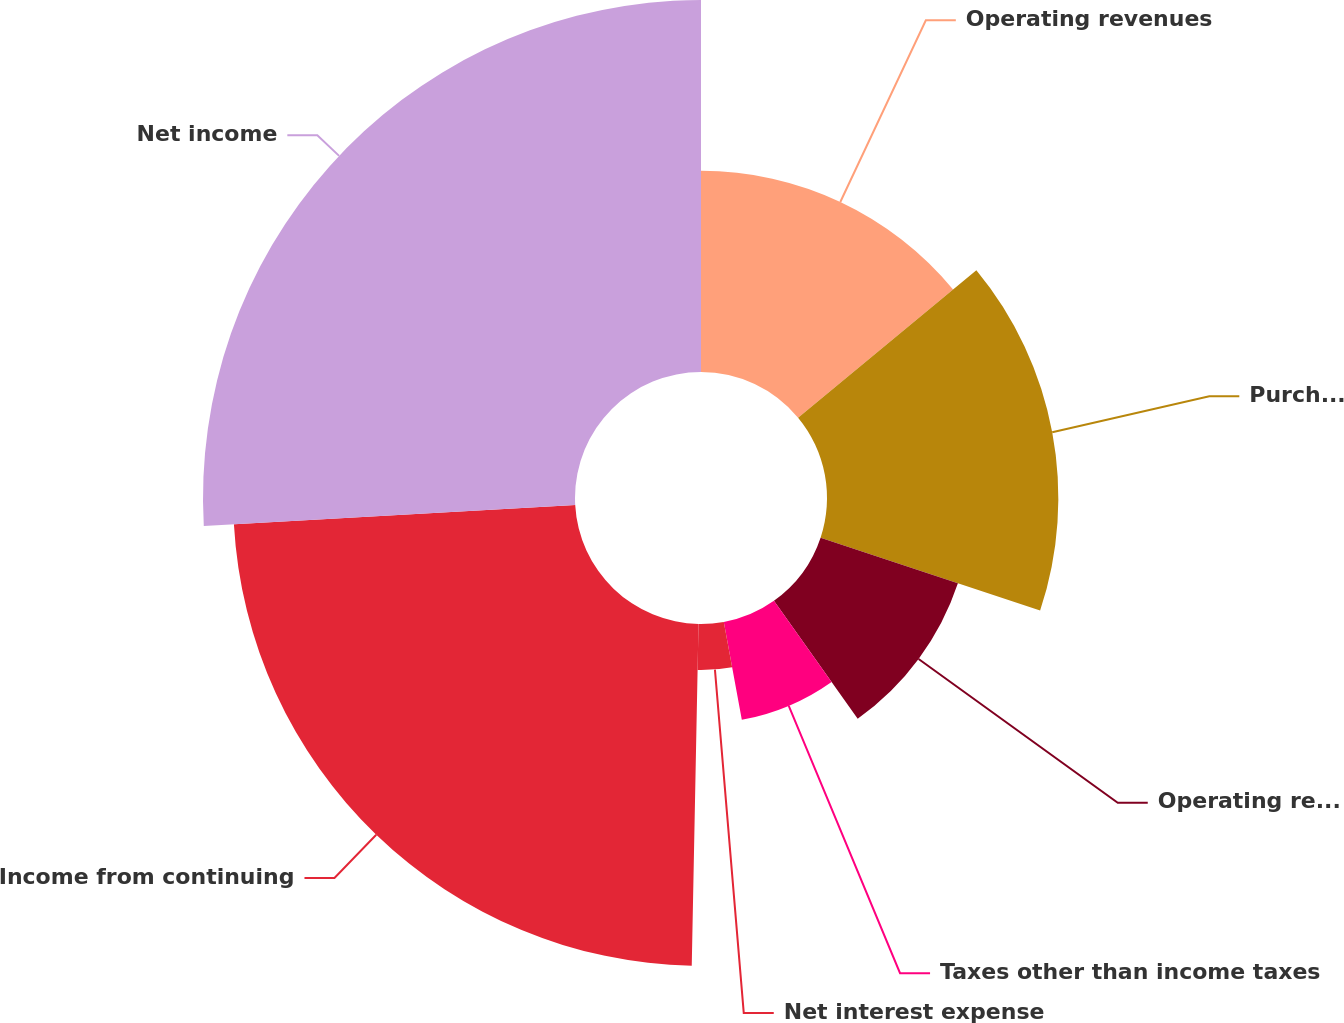<chart> <loc_0><loc_0><loc_500><loc_500><pie_chart><fcel>Operating revenues<fcel>Purchased power<fcel>Operating revenues less<fcel>Taxes other than income taxes<fcel>Net interest expense<fcel>Income from continuing<fcel>Net income<nl><fcel>14.0%<fcel>16.1%<fcel>10.07%<fcel>6.93%<fcel>3.21%<fcel>23.79%<fcel>25.89%<nl></chart> 